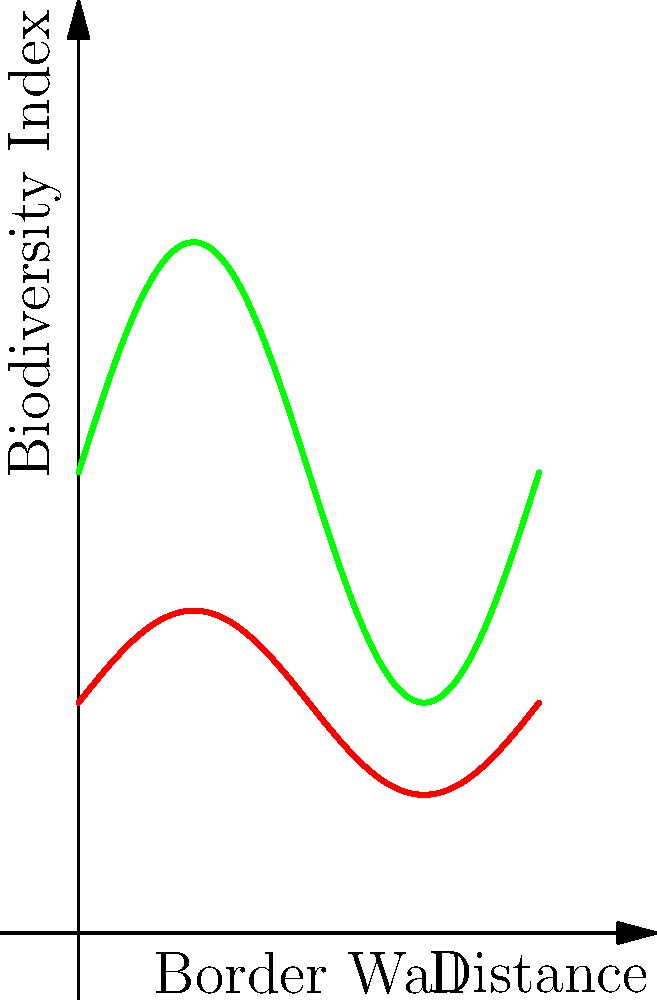Based on the satellite image analysis represented in the graph, which shows biodiversity indices before and after border wall construction, what can be concluded about the impact of the wall on local ecosystems? To analyze the impact of border wall construction on local ecosystems, we need to examine the changes in the biodiversity index before and after construction:

1. Before construction (green line):
   - The biodiversity index fluctuates between approximately 0.5 and 1.5.
   - The average biodiversity index is around 1.0.

2. After construction (red line):
   - The biodiversity index fluctuates between approximately 0.3 and 0.7.
   - The average biodiversity index is around 0.5.

3. Comparing the two lines:
   - The "After" line is consistently lower than the "Before" line.
   - The amplitude of fluctuations in biodiversity has decreased.

4. Calculating the change:
   - The average biodiversity index has decreased by about 50% (from 1.0 to 0.5).

5. Interpreting the results:
   - The significant decrease in biodiversity index suggests a negative impact on local ecosystems.
   - The reduced amplitude of fluctuations may indicate a loss of habitat diversity.

6. Considering economic implications:
   - Reduced biodiversity could affect local industries dependent on ecosystem services (e.g., agriculture, tourism).
   - Potential long-term costs for ecosystem restoration or mitigation measures.
Answer: Significant negative impact on local ecosystems, with approximately 50% reduction in biodiversity index. 